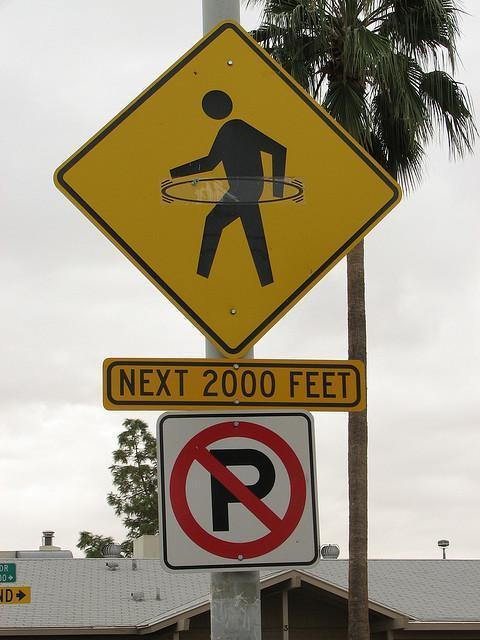How many signs are on the pole?
Give a very brief answer. 3. How many signs are there?
Give a very brief answer. 3. How many signs are on the post?
Give a very brief answer. 3. 